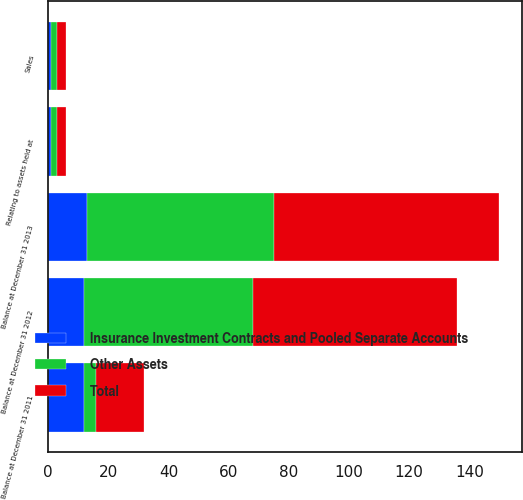Convert chart. <chart><loc_0><loc_0><loc_500><loc_500><stacked_bar_chart><ecel><fcel>Balance at December 31 2011<fcel>Relating to assets held at<fcel>Sales<fcel>Balance at December 31 2012<fcel>Balance at December 31 2013<nl><fcel>Insurance Investment Contracts and Pooled Separate Accounts<fcel>12<fcel>1<fcel>1<fcel>12<fcel>13<nl><fcel>Other Assets<fcel>4<fcel>2<fcel>2<fcel>56<fcel>62<nl><fcel>Total<fcel>16<fcel>3<fcel>3<fcel>68<fcel>75<nl></chart> 